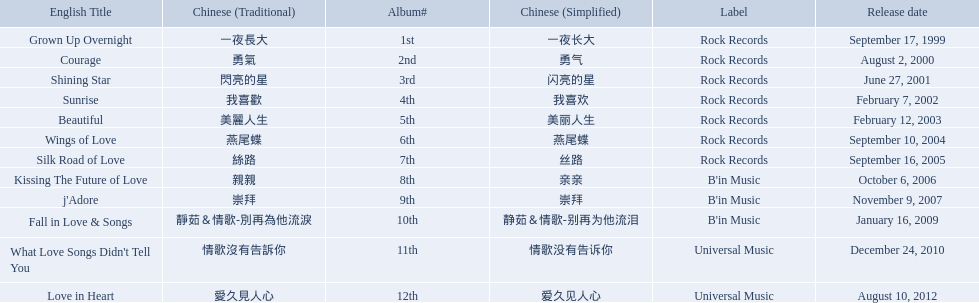Which english titles were released during even years? Courage, Sunrise, Silk Road of Love, Kissing The Future of Love, What Love Songs Didn't Tell You, Love in Heart. Out of the following, which one was released under b's in music? Kissing The Future of Love. Write the full table. {'header': ['English Title', 'Chinese (Traditional)', 'Album#', 'Chinese (Simplified)', 'Label', 'Release date'], 'rows': [['Grown Up Overnight', '一夜長大', '1st', '一夜长大', 'Rock Records', 'September 17, 1999'], ['Courage', '勇氣', '2nd', '勇气', 'Rock Records', 'August 2, 2000'], ['Shining Star', '閃亮的星', '3rd', '闪亮的星', 'Rock Records', 'June 27, 2001'], ['Sunrise', '我喜歡', '4th', '我喜欢', 'Rock Records', 'February 7, 2002'], ['Beautiful', '美麗人生', '5th', '美丽人生', 'Rock Records', 'February 12, 2003'], ['Wings of Love', '燕尾蝶', '6th', '燕尾蝶', 'Rock Records', 'September 10, 2004'], ['Silk Road of Love', '絲路', '7th', '丝路', 'Rock Records', 'September 16, 2005'], ['Kissing The Future of Love', '親親', '8th', '亲亲', "B'in Music", 'October 6, 2006'], ["j'Adore", '崇拜', '9th', '崇拜', "B'in Music", 'November 9, 2007'], ['Fall in Love & Songs', '靜茹＆情歌-別再為他流淚', '10th', '静茹＆情歌-别再为他流泪', "B'in Music", 'January 16, 2009'], ["What Love Songs Didn't Tell You", '情歌沒有告訴你', '11th', '情歌没有告诉你', 'Universal Music', 'December 24, 2010'], ['Love in Heart', '愛久見人心', '12th', '爱久见人心', 'Universal Music', 'August 10, 2012']]} 